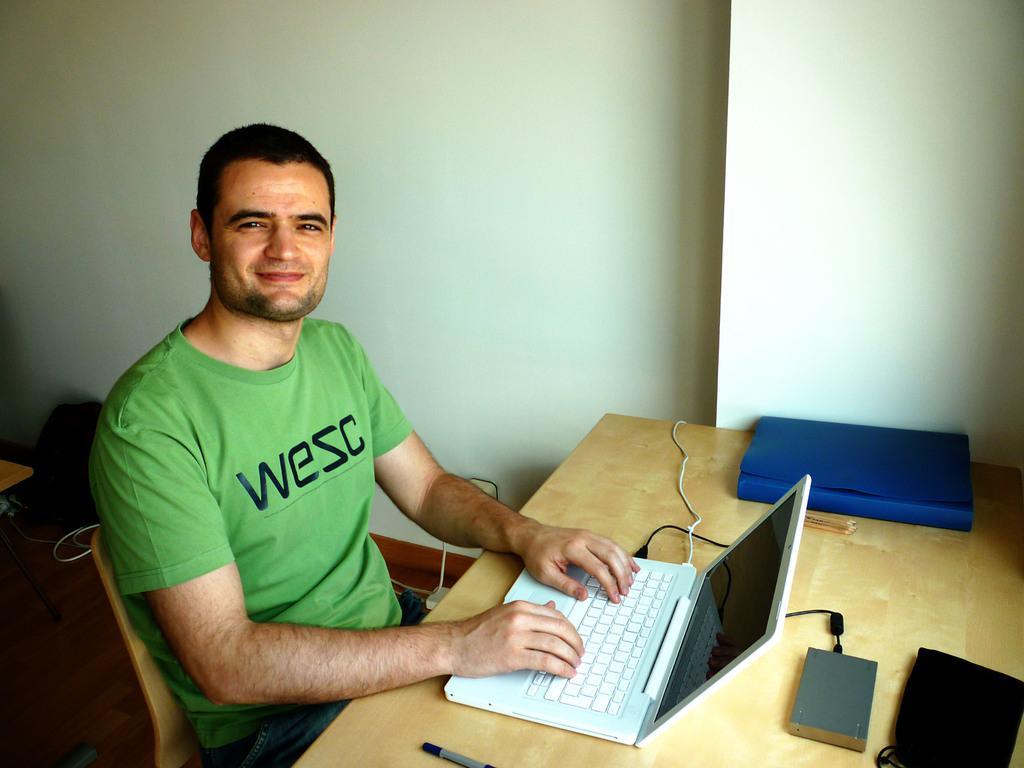Can you describe this image briefly? There is a man who is sitting on the chair. He is smiling. This is table. On the table there is a laptop and a book. On the background there is a wall and this is floor. 